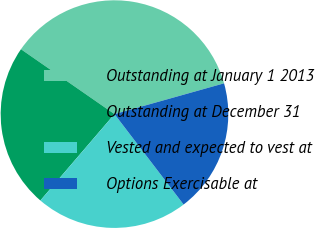Convert chart to OTSL. <chart><loc_0><loc_0><loc_500><loc_500><pie_chart><fcel>Outstanding at January 1 2013<fcel>Outstanding at December 31<fcel>Vested and expected to vest at<fcel>Options Exercisable at<nl><fcel>35.99%<fcel>23.37%<fcel>21.67%<fcel>18.97%<nl></chart> 